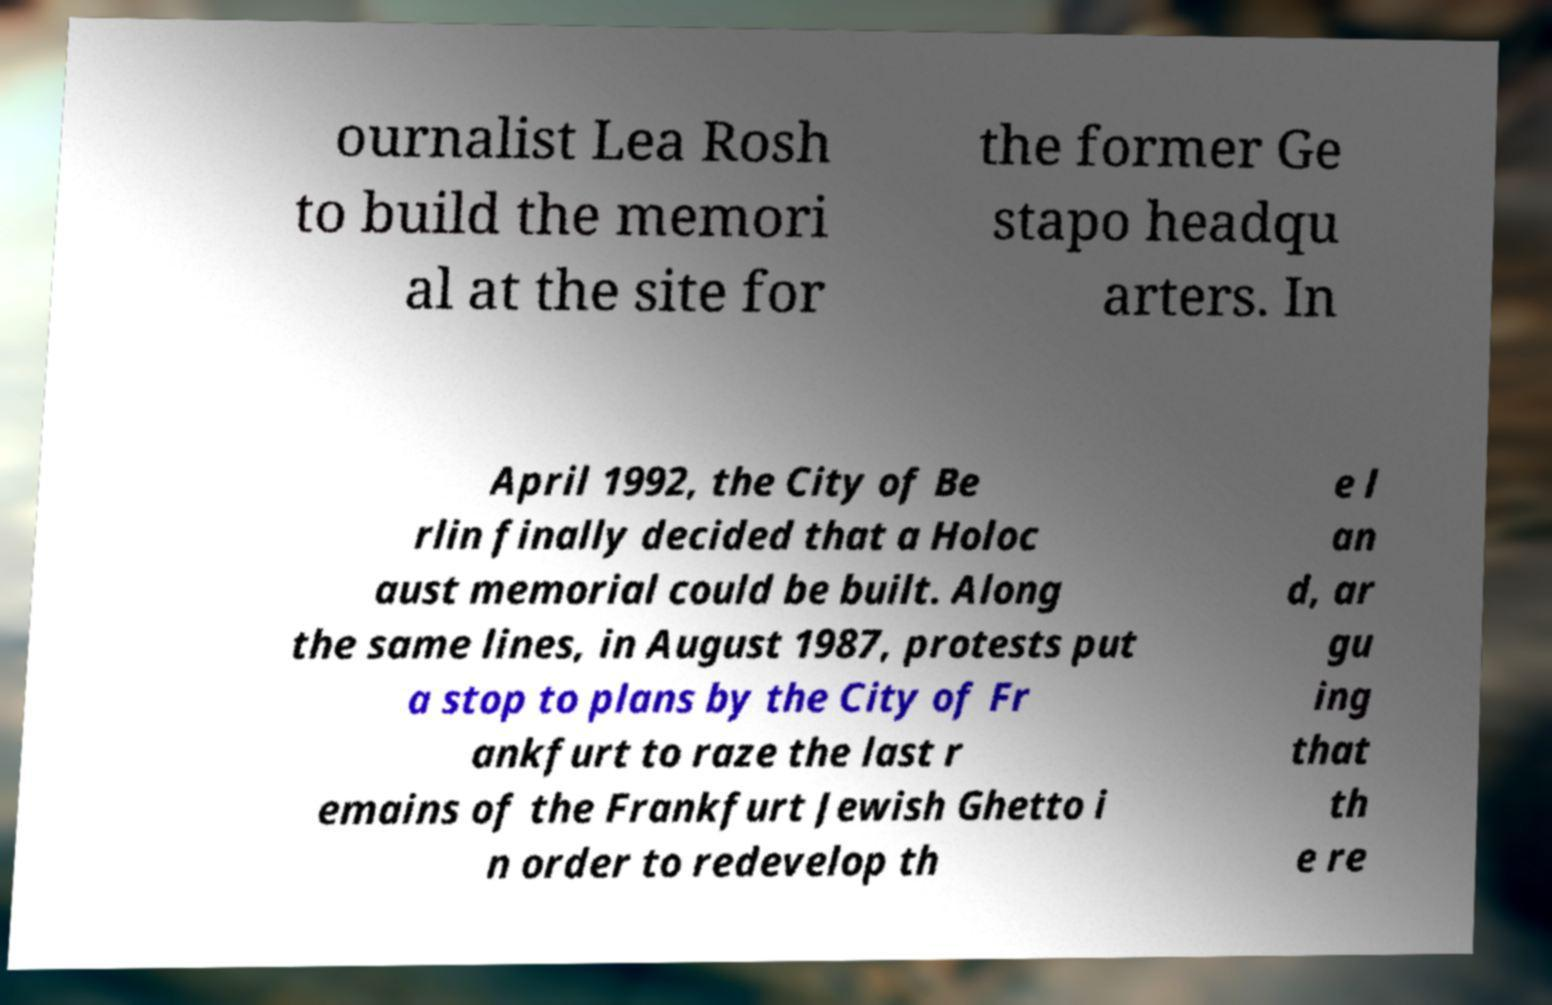For documentation purposes, I need the text within this image transcribed. Could you provide that? ournalist Lea Rosh to build the memori al at the site for the former Ge stapo headqu arters. In April 1992, the City of Be rlin finally decided that a Holoc aust memorial could be built. Along the same lines, in August 1987, protests put a stop to plans by the City of Fr ankfurt to raze the last r emains of the Frankfurt Jewish Ghetto i n order to redevelop th e l an d, ar gu ing that th e re 